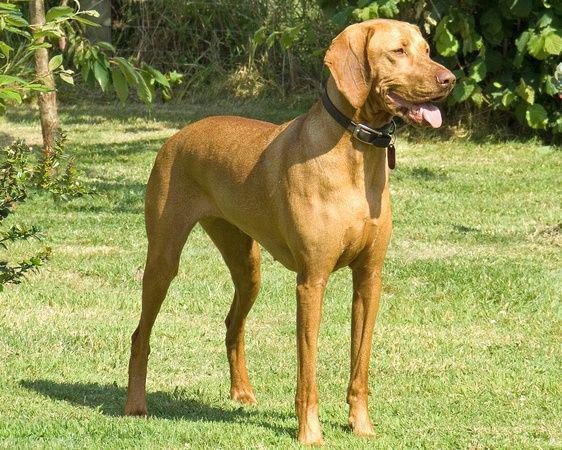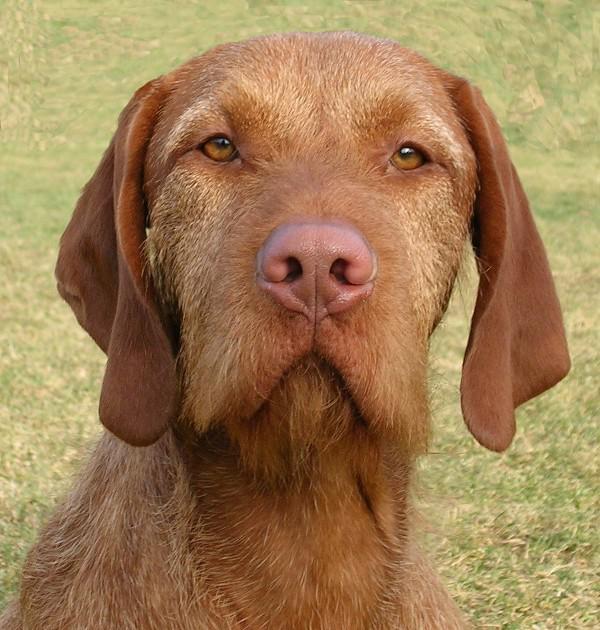The first image is the image on the left, the second image is the image on the right. Assess this claim about the two images: "Each image contains one red-orange adult dog, and one image shows a dog in a black collar standing on all fours in the grass facing rightward.". Correct or not? Answer yes or no. Yes. The first image is the image on the left, the second image is the image on the right. Examine the images to the left and right. Is the description "The dog in one of the images is standing in the grass." accurate? Answer yes or no. Yes. 